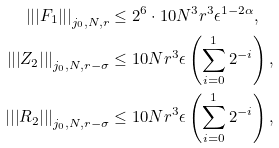Convert formula to latex. <formula><loc_0><loc_0><loc_500><loc_500>\left | \left | \left | F _ { 1 } \right | \right | \right | _ { j _ { 0 } , N , r } & \leq { 2 ^ { 6 } } \cdot 1 0 N ^ { 3 } r ^ { 3 } \epsilon ^ { 1 - 2 \alpha } , \\ \left | \left | \left | Z _ { 2 } \right | \right | \right | _ { j _ { 0 } , N , r - \sigma } & \leq 1 0 N r ^ { 3 } \epsilon \left ( \sum _ { i = 0 } ^ { 1 } 2 ^ { - i } \right ) , \\ \left | \left | \left | R _ { 2 } \right | \right | \right | _ { j _ { 0 } , N , r - \sigma } & \leq 1 0 N r ^ { 3 } \epsilon \left ( \sum _ { i = 0 } ^ { 1 } 2 ^ { - i } \right ) ,</formula> 